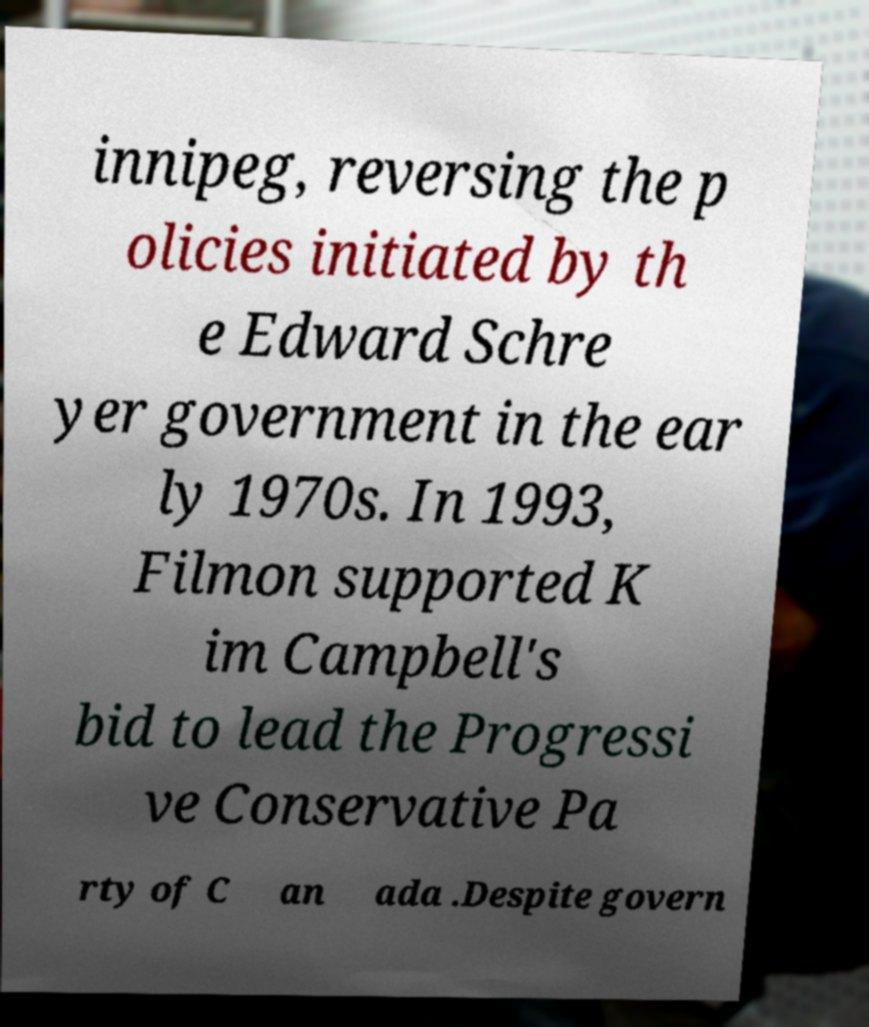Please read and relay the text visible in this image. What does it say? innipeg, reversing the p olicies initiated by th e Edward Schre yer government in the ear ly 1970s. In 1993, Filmon supported K im Campbell's bid to lead the Progressi ve Conservative Pa rty of C an ada .Despite govern 